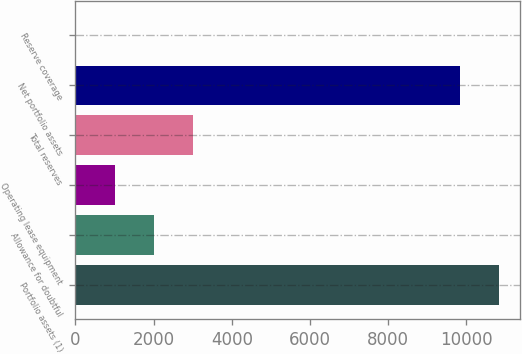Convert chart to OTSL. <chart><loc_0><loc_0><loc_500><loc_500><bar_chart><fcel>Portfolio assets (1)<fcel>Allowance for doubtful<fcel>Operating lease equipment<fcel>Total reserves<fcel>Net portfolio assets<fcel>Reserve coverage<nl><fcel>10839.5<fcel>2004.84<fcel>1003.32<fcel>3006.36<fcel>9838<fcel>1.8<nl></chart> 